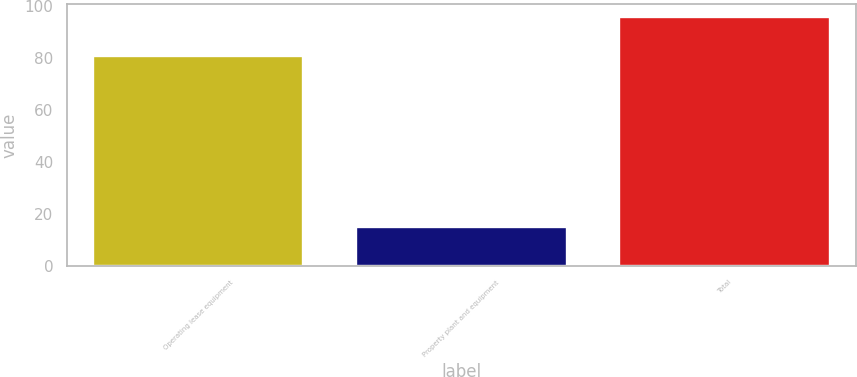Convert chart. <chart><loc_0><loc_0><loc_500><loc_500><bar_chart><fcel>Operating lease equipment<fcel>Property plant and equipment<fcel>Total<nl><fcel>81<fcel>15<fcel>96<nl></chart> 